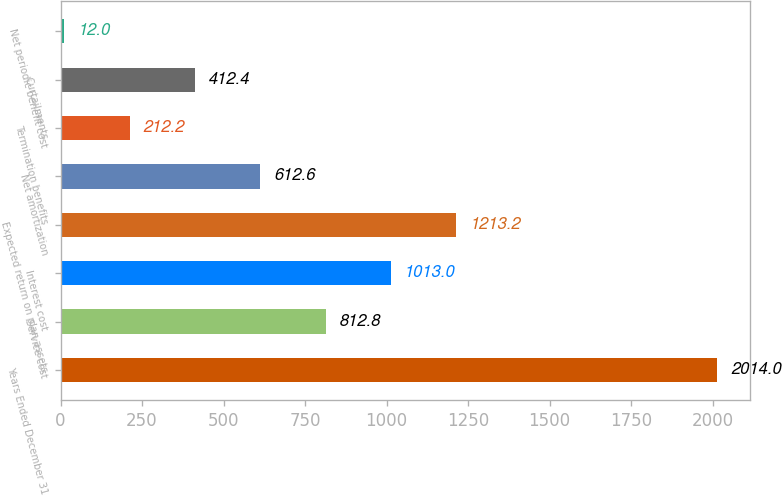<chart> <loc_0><loc_0><loc_500><loc_500><bar_chart><fcel>Years Ended December 31<fcel>Service cost<fcel>Interest cost<fcel>Expected return on plan assets<fcel>Net amortization<fcel>Termination benefits<fcel>Curtailments<fcel>Net periodic benefit cost<nl><fcel>2014<fcel>812.8<fcel>1013<fcel>1213.2<fcel>612.6<fcel>212.2<fcel>412.4<fcel>12<nl></chart> 